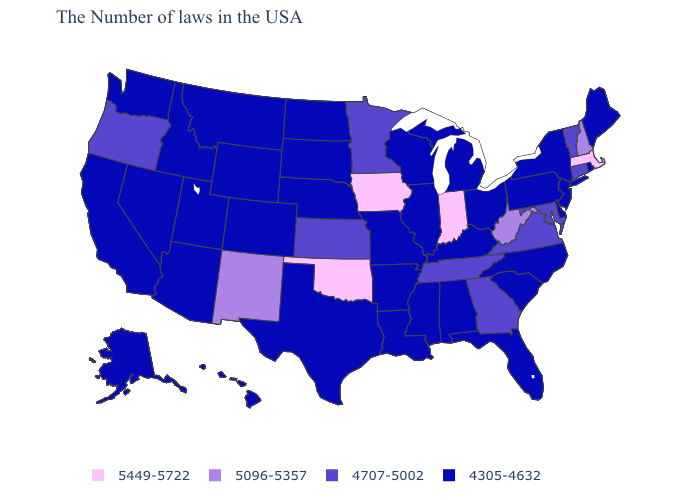How many symbols are there in the legend?
Keep it brief. 4. Does Missouri have the lowest value in the USA?
Give a very brief answer. Yes. Does Nebraska have the lowest value in the USA?
Concise answer only. Yes. Does New York have the lowest value in the USA?
Quick response, please. Yes. What is the lowest value in states that border Montana?
Write a very short answer. 4305-4632. Does Missouri have a lower value than Nevada?
Answer briefly. No. Name the states that have a value in the range 4305-4632?
Concise answer only. Maine, Rhode Island, New York, New Jersey, Delaware, Pennsylvania, North Carolina, South Carolina, Ohio, Florida, Michigan, Kentucky, Alabama, Wisconsin, Illinois, Mississippi, Louisiana, Missouri, Arkansas, Nebraska, Texas, South Dakota, North Dakota, Wyoming, Colorado, Utah, Montana, Arizona, Idaho, Nevada, California, Washington, Alaska, Hawaii. Among the states that border Iowa , which have the lowest value?
Give a very brief answer. Wisconsin, Illinois, Missouri, Nebraska, South Dakota. What is the value of New Mexico?
Concise answer only. 5096-5357. Does the map have missing data?
Short answer required. No. What is the value of Connecticut?
Short answer required. 4707-5002. Among the states that border Illinois , which have the lowest value?
Give a very brief answer. Kentucky, Wisconsin, Missouri. What is the value of Colorado?
Quick response, please. 4305-4632. Among the states that border Texas , which have the lowest value?
Concise answer only. Louisiana, Arkansas. 